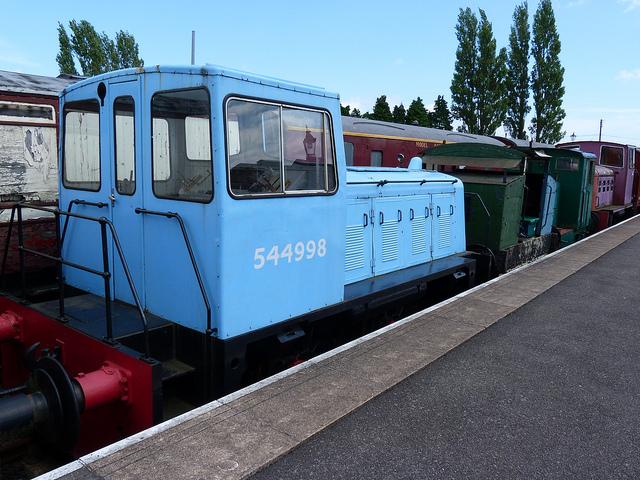Is the engine running?
Write a very short answer. No. Is it a cloudy day?
Write a very short answer. No. Is that train blue?
Keep it brief. Yes. What color is the engine?
Be succinct. Blue. 